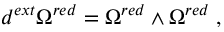Convert formula to latex. <formula><loc_0><loc_0><loc_500><loc_500>d ^ { e x t } \Omega ^ { r e d } = \Omega ^ { r e d } \wedge \Omega ^ { r e d } \, ,</formula> 